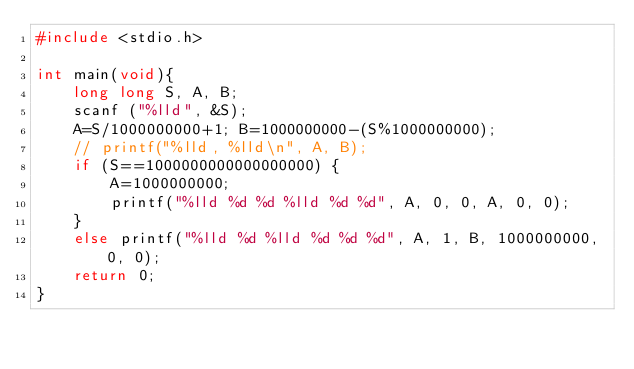Convert code to text. <code><loc_0><loc_0><loc_500><loc_500><_C_>#include <stdio.h>

int main(void){
    long long S, A, B;
    scanf ("%lld", &S);
    A=S/1000000000+1; B=1000000000-(S%1000000000);
    // printf("%lld, %lld\n", A, B);
    if (S==1000000000000000000) {
        A=1000000000;
        printf("%lld %d %d %lld %d %d", A, 0, 0, A, 0, 0);
    }
    else printf("%lld %d %lld %d %d %d", A, 1, B, 1000000000, 0, 0);
    return 0;
}</code> 